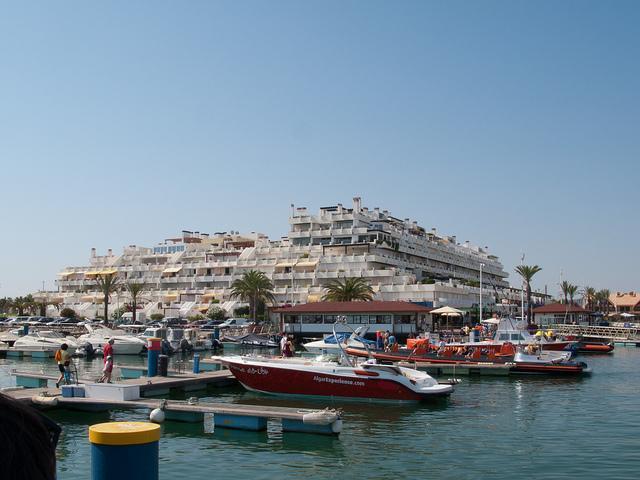What does the side of the nearest boat want you to visit?
Choose the correct response, then elucidate: 'Answer: answer
Rationale: rationale.'
Options: Website, brazil, japan, restaurant. Answer: website.
Rationale: There is a url ending in .com on the side of the boat. 